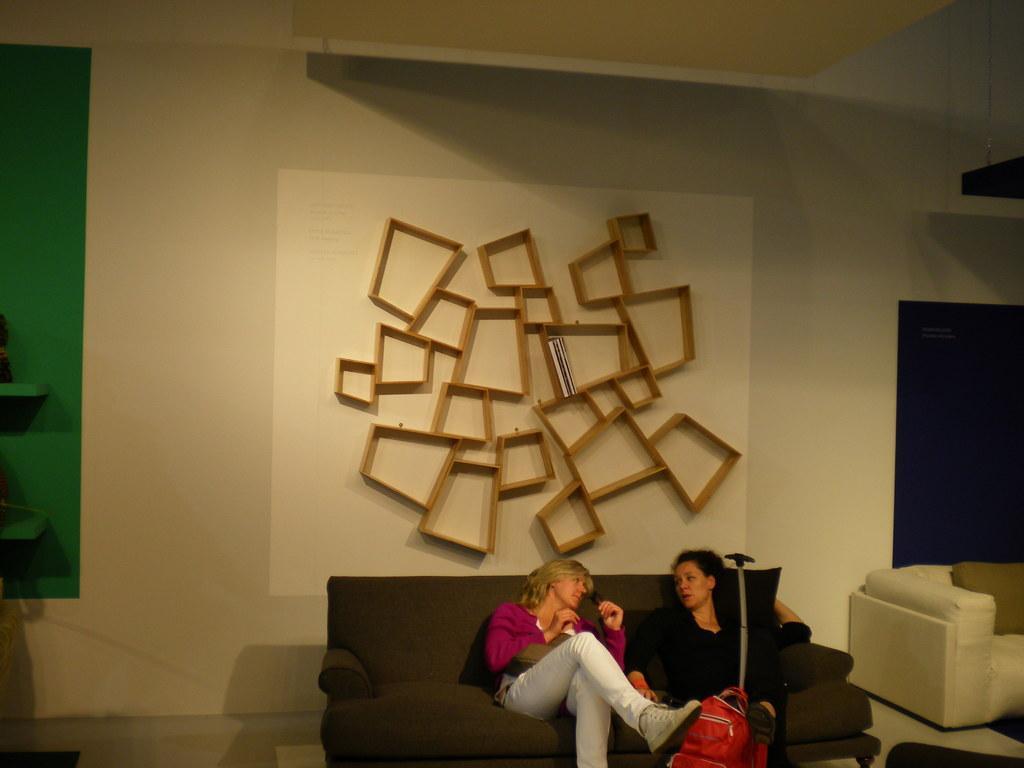In one or two sentences, can you explain what this image depicts? This picture shows two women seated on the sofa and a woman holding a trolley bag and we see wooden cupboard on their back to the wall 